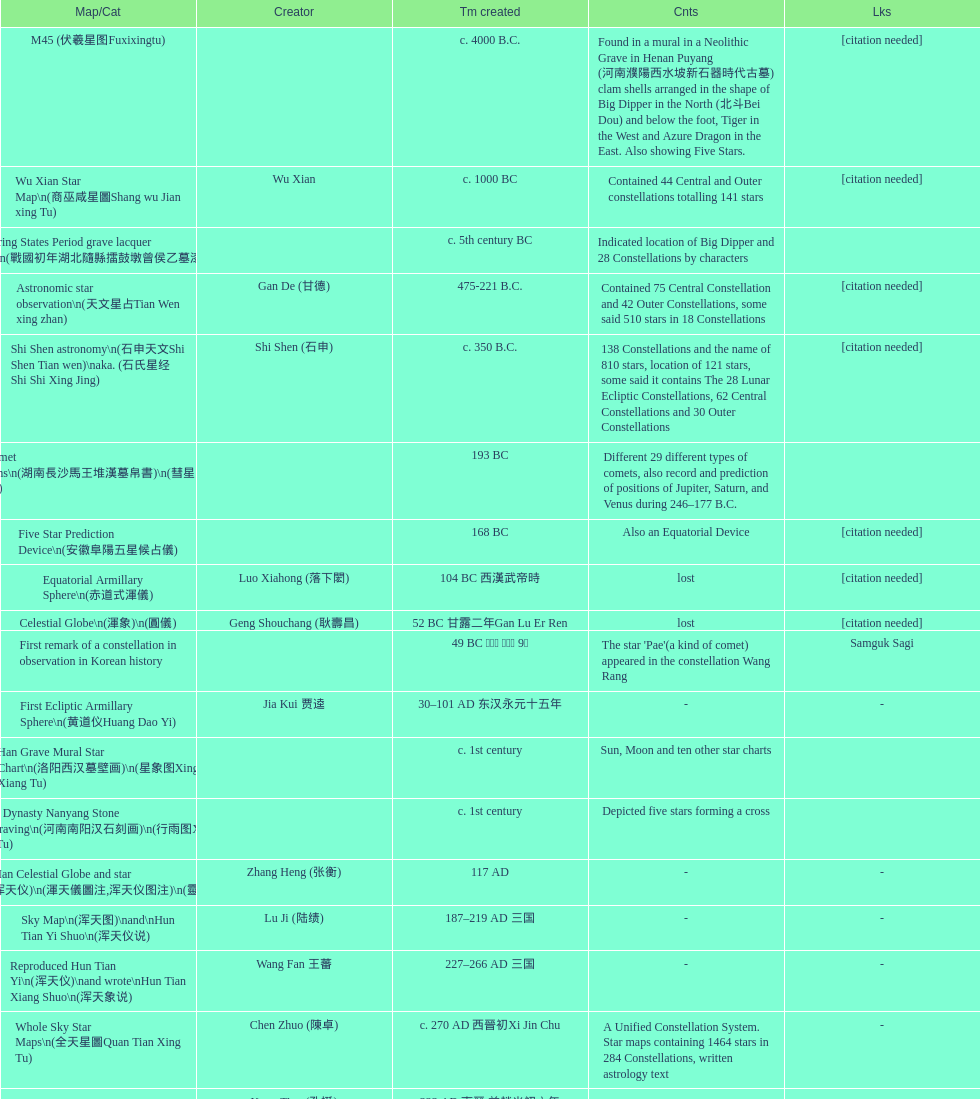What is the name of the oldest map/catalog? M45. 